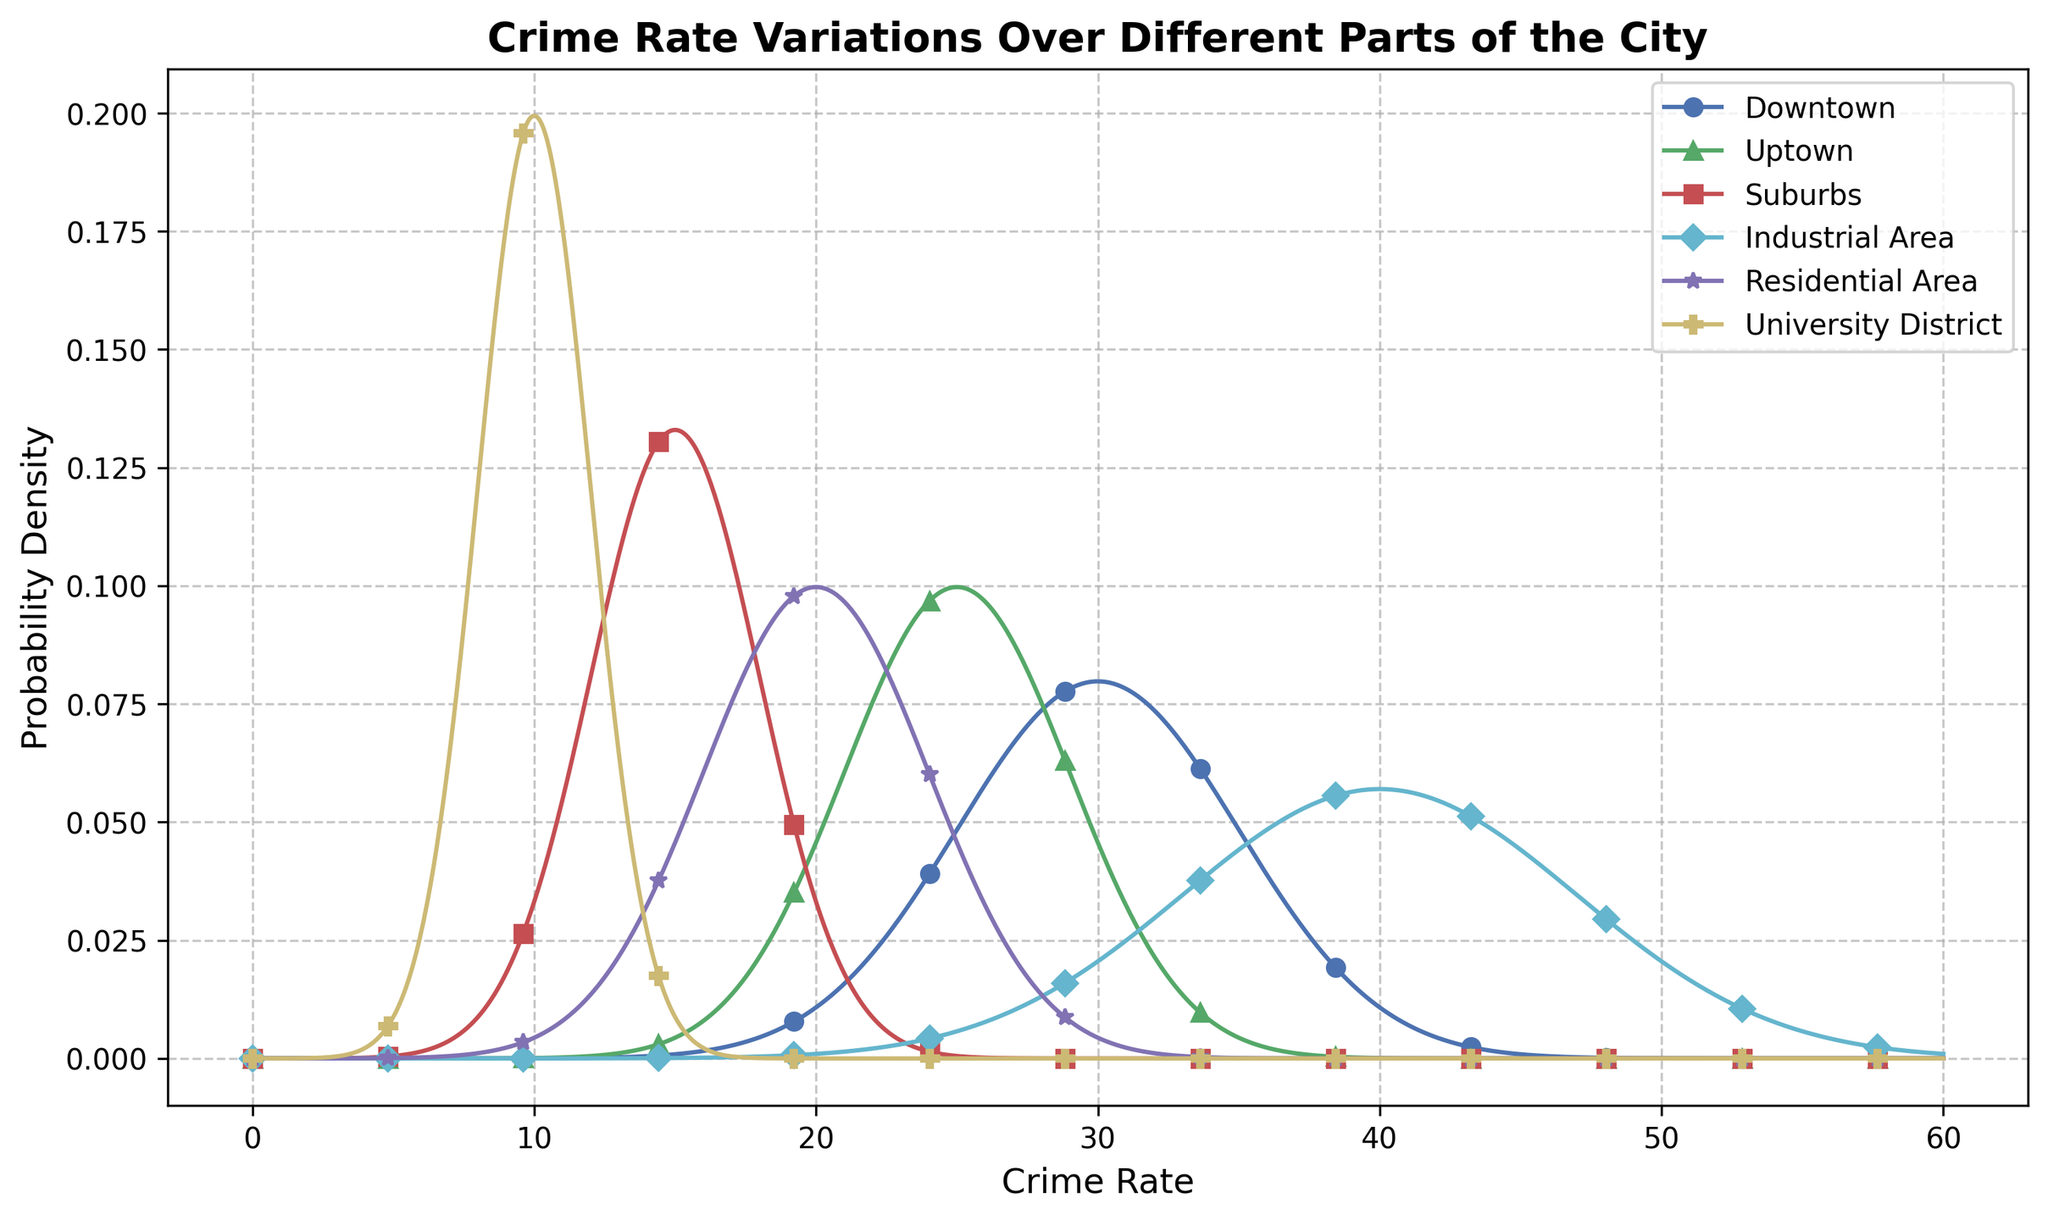What location has the highest peak in the plot? The height of the peak indicates the highest probability density. The Industrial Area has the tallest peak, which corresponds to the highest crime rate in the plot.
Answer: Industrial Area Which location has the lowest mean crime rate? The plot shows that the University District has the lowest mean crime rate, as indicated by its position on the x-axis.
Answer: University District How does the crime rate in Downtown compare to Uptown? Both Downtown and Uptown exhibit high crime rates, but Downtown's peak is higher and occurs at a slightly higher crime rate than Uptown. This suggests that Downtown has a greater average crime rate with a higher probability density.
Answer: Downtown has a higher crime rate What is the difference between the mean crime rate of Downtown and Suburbs? The mean crime rate for Downtown is 30, and for the Suburbs, it is 15. Subtracting the Suburbs' mean from Downtown’s mean gives 30 - 15.
Answer: 15 Which area has the widest variation in crime rate? The width of the distribution (spread along the x-axis) indicates the variation. The Industrial Area shows the widest spread, implying the greatest standard deviation in crime rates.
Answer: Industrial Area What is the mean of the mean crime rates across all locations? Adding the mean crime rates (30 + 25 + 15 + 40 + 20 + 10) gives 140. Dividing this by the number of locations (6), the mean of the mean crime rates is calculated as 140/6.
Answer: 23.33 Between Uptown and Residential Area, which one has a higher variability in crime rates? The standard deviation indicates variability. Uptown has a standard deviation of 4, and the Residential Area also has a standard deviation of 4. Since these are equal, both have the same variability.
Answer: Equal Which distribution is the narrowest on the plot? The University District’s probability density function appears the narrowest, indicating the least variability (smallest standard deviation of 2).
Answer: University District If you add the standard deviations of Downtown and University District, what do you get? The standard deviations are 5 (Downtown) and 2 (University District). Summing these, 5 + 2 equals 7.
Answer: 7 What does the color of the Downtown curve represent in the plot? The colors are used to uniquely identify each location's distribution. Downtown is represented with a blue curve.
Answer: Blue 